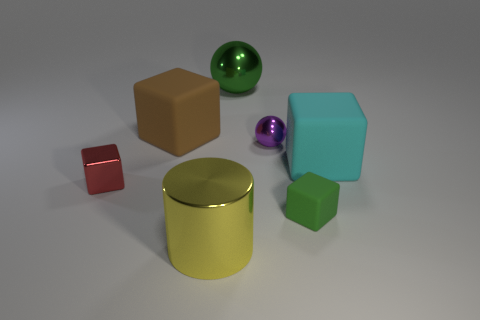There is a large brown thing that is the same shape as the red thing; what is its material?
Provide a succinct answer. Rubber. What shape is the tiny metallic thing on the right side of the rubber object that is behind the big cyan cube?
Your answer should be very brief. Sphere. Is the sphere that is in front of the large green thing made of the same material as the big green sphere?
Your response must be concise. Yes. Is the number of small spheres in front of the cyan rubber cube the same as the number of tiny shiny objects behind the big metal sphere?
Keep it short and to the point. Yes. What is the material of the block that is the same color as the big ball?
Offer a terse response. Rubber. What number of tiny cubes are to the left of the large metal thing that is behind the large yellow metal cylinder?
Keep it short and to the point. 1. Do the large rubber object on the right side of the big ball and the big cube that is on the left side of the purple shiny thing have the same color?
Your response must be concise. No. There is a cyan block that is the same size as the brown rubber object; what is its material?
Your response must be concise. Rubber. What is the shape of the large metal thing on the left side of the green thing that is behind the big brown rubber block that is right of the red object?
Make the answer very short. Cylinder. What shape is the other rubber object that is the same size as the brown thing?
Provide a short and direct response. Cube. 